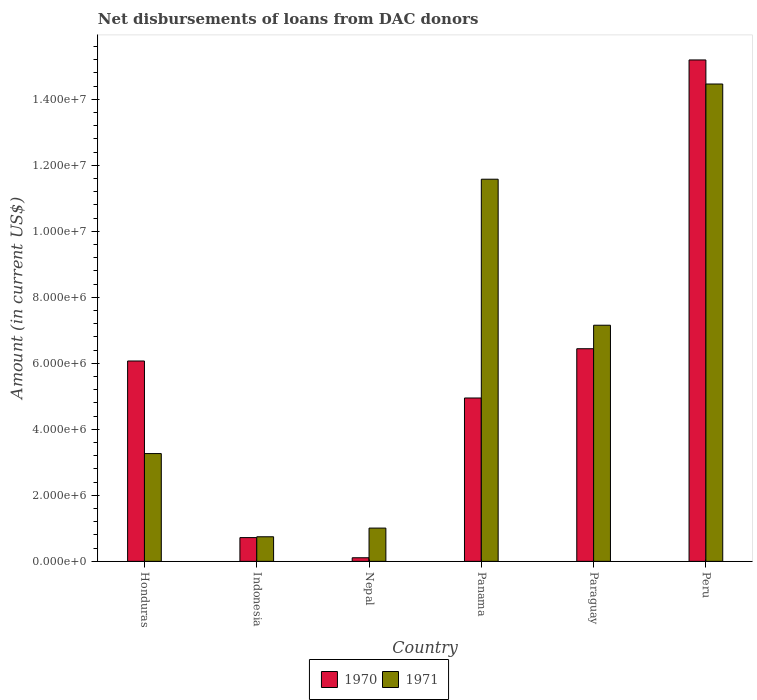How many different coloured bars are there?
Ensure brevity in your answer.  2. How many bars are there on the 5th tick from the right?
Provide a short and direct response. 2. What is the label of the 1st group of bars from the left?
Provide a short and direct response. Honduras. What is the amount of loans disbursed in 1970 in Honduras?
Give a very brief answer. 6.07e+06. Across all countries, what is the maximum amount of loans disbursed in 1970?
Your answer should be compact. 1.52e+07. Across all countries, what is the minimum amount of loans disbursed in 1970?
Offer a terse response. 1.09e+05. In which country was the amount of loans disbursed in 1971 maximum?
Your response must be concise. Peru. In which country was the amount of loans disbursed in 1971 minimum?
Keep it short and to the point. Indonesia. What is the total amount of loans disbursed in 1971 in the graph?
Make the answer very short. 3.82e+07. What is the difference between the amount of loans disbursed in 1970 in Honduras and that in Paraguay?
Your response must be concise. -3.72e+05. What is the difference between the amount of loans disbursed in 1970 in Indonesia and the amount of loans disbursed in 1971 in Paraguay?
Offer a terse response. -6.44e+06. What is the average amount of loans disbursed in 1970 per country?
Your answer should be compact. 5.58e+06. What is the difference between the amount of loans disbursed of/in 1970 and amount of loans disbursed of/in 1971 in Honduras?
Give a very brief answer. 2.80e+06. What is the ratio of the amount of loans disbursed in 1970 in Panama to that in Peru?
Offer a terse response. 0.33. What is the difference between the highest and the second highest amount of loans disbursed in 1970?
Offer a terse response. 8.75e+06. What is the difference between the highest and the lowest amount of loans disbursed in 1970?
Provide a short and direct response. 1.51e+07. Is the sum of the amount of loans disbursed in 1971 in Paraguay and Peru greater than the maximum amount of loans disbursed in 1970 across all countries?
Provide a succinct answer. Yes. What does the 2nd bar from the left in Indonesia represents?
Ensure brevity in your answer.  1971. What does the 1st bar from the right in Indonesia represents?
Offer a terse response. 1971. How many bars are there?
Your answer should be very brief. 12. How many countries are there in the graph?
Your response must be concise. 6. What is the difference between two consecutive major ticks on the Y-axis?
Offer a terse response. 2.00e+06. Does the graph contain any zero values?
Provide a short and direct response. No. Does the graph contain grids?
Offer a terse response. No. What is the title of the graph?
Offer a terse response. Net disbursements of loans from DAC donors. Does "1996" appear as one of the legend labels in the graph?
Your response must be concise. No. What is the Amount (in current US$) in 1970 in Honduras?
Your response must be concise. 6.07e+06. What is the Amount (in current US$) in 1971 in Honduras?
Your answer should be very brief. 3.27e+06. What is the Amount (in current US$) of 1970 in Indonesia?
Your response must be concise. 7.20e+05. What is the Amount (in current US$) in 1971 in Indonesia?
Keep it short and to the point. 7.45e+05. What is the Amount (in current US$) of 1970 in Nepal?
Your answer should be very brief. 1.09e+05. What is the Amount (in current US$) of 1971 in Nepal?
Your response must be concise. 1.01e+06. What is the Amount (in current US$) in 1970 in Panama?
Offer a terse response. 4.95e+06. What is the Amount (in current US$) of 1971 in Panama?
Provide a succinct answer. 1.16e+07. What is the Amount (in current US$) in 1970 in Paraguay?
Keep it short and to the point. 6.44e+06. What is the Amount (in current US$) in 1971 in Paraguay?
Ensure brevity in your answer.  7.16e+06. What is the Amount (in current US$) of 1970 in Peru?
Your answer should be compact. 1.52e+07. What is the Amount (in current US$) in 1971 in Peru?
Provide a succinct answer. 1.45e+07. Across all countries, what is the maximum Amount (in current US$) of 1970?
Ensure brevity in your answer.  1.52e+07. Across all countries, what is the maximum Amount (in current US$) in 1971?
Provide a succinct answer. 1.45e+07. Across all countries, what is the minimum Amount (in current US$) of 1970?
Your answer should be compact. 1.09e+05. Across all countries, what is the minimum Amount (in current US$) in 1971?
Offer a very short reply. 7.45e+05. What is the total Amount (in current US$) in 1970 in the graph?
Provide a succinct answer. 3.35e+07. What is the total Amount (in current US$) in 1971 in the graph?
Your answer should be compact. 3.82e+07. What is the difference between the Amount (in current US$) in 1970 in Honduras and that in Indonesia?
Keep it short and to the point. 5.35e+06. What is the difference between the Amount (in current US$) of 1971 in Honduras and that in Indonesia?
Your answer should be very brief. 2.52e+06. What is the difference between the Amount (in current US$) in 1970 in Honduras and that in Nepal?
Offer a very short reply. 5.96e+06. What is the difference between the Amount (in current US$) of 1971 in Honduras and that in Nepal?
Your answer should be compact. 2.26e+06. What is the difference between the Amount (in current US$) of 1970 in Honduras and that in Panama?
Make the answer very short. 1.12e+06. What is the difference between the Amount (in current US$) in 1971 in Honduras and that in Panama?
Make the answer very short. -8.31e+06. What is the difference between the Amount (in current US$) in 1970 in Honduras and that in Paraguay?
Your answer should be compact. -3.72e+05. What is the difference between the Amount (in current US$) of 1971 in Honduras and that in Paraguay?
Keep it short and to the point. -3.89e+06. What is the difference between the Amount (in current US$) of 1970 in Honduras and that in Peru?
Offer a very short reply. -9.12e+06. What is the difference between the Amount (in current US$) in 1971 in Honduras and that in Peru?
Your answer should be very brief. -1.12e+07. What is the difference between the Amount (in current US$) in 1970 in Indonesia and that in Nepal?
Make the answer very short. 6.11e+05. What is the difference between the Amount (in current US$) in 1971 in Indonesia and that in Nepal?
Give a very brief answer. -2.63e+05. What is the difference between the Amount (in current US$) of 1970 in Indonesia and that in Panama?
Your answer should be compact. -4.23e+06. What is the difference between the Amount (in current US$) in 1971 in Indonesia and that in Panama?
Make the answer very short. -1.08e+07. What is the difference between the Amount (in current US$) in 1970 in Indonesia and that in Paraguay?
Offer a very short reply. -5.72e+06. What is the difference between the Amount (in current US$) of 1971 in Indonesia and that in Paraguay?
Provide a succinct answer. -6.41e+06. What is the difference between the Amount (in current US$) in 1970 in Indonesia and that in Peru?
Provide a short and direct response. -1.45e+07. What is the difference between the Amount (in current US$) of 1971 in Indonesia and that in Peru?
Provide a short and direct response. -1.37e+07. What is the difference between the Amount (in current US$) in 1970 in Nepal and that in Panama?
Give a very brief answer. -4.84e+06. What is the difference between the Amount (in current US$) in 1971 in Nepal and that in Panama?
Your response must be concise. -1.06e+07. What is the difference between the Amount (in current US$) of 1970 in Nepal and that in Paraguay?
Your answer should be compact. -6.33e+06. What is the difference between the Amount (in current US$) in 1971 in Nepal and that in Paraguay?
Ensure brevity in your answer.  -6.15e+06. What is the difference between the Amount (in current US$) of 1970 in Nepal and that in Peru?
Provide a short and direct response. -1.51e+07. What is the difference between the Amount (in current US$) of 1971 in Nepal and that in Peru?
Ensure brevity in your answer.  -1.35e+07. What is the difference between the Amount (in current US$) of 1970 in Panama and that in Paraguay?
Make the answer very short. -1.49e+06. What is the difference between the Amount (in current US$) of 1971 in Panama and that in Paraguay?
Your response must be concise. 4.42e+06. What is the difference between the Amount (in current US$) in 1970 in Panama and that in Peru?
Offer a very short reply. -1.02e+07. What is the difference between the Amount (in current US$) in 1971 in Panama and that in Peru?
Keep it short and to the point. -2.88e+06. What is the difference between the Amount (in current US$) in 1970 in Paraguay and that in Peru?
Keep it short and to the point. -8.75e+06. What is the difference between the Amount (in current US$) of 1971 in Paraguay and that in Peru?
Offer a terse response. -7.31e+06. What is the difference between the Amount (in current US$) of 1970 in Honduras and the Amount (in current US$) of 1971 in Indonesia?
Provide a succinct answer. 5.33e+06. What is the difference between the Amount (in current US$) of 1970 in Honduras and the Amount (in current US$) of 1971 in Nepal?
Your response must be concise. 5.06e+06. What is the difference between the Amount (in current US$) of 1970 in Honduras and the Amount (in current US$) of 1971 in Panama?
Provide a succinct answer. -5.51e+06. What is the difference between the Amount (in current US$) in 1970 in Honduras and the Amount (in current US$) in 1971 in Paraguay?
Offer a very short reply. -1.08e+06. What is the difference between the Amount (in current US$) of 1970 in Honduras and the Amount (in current US$) of 1971 in Peru?
Give a very brief answer. -8.39e+06. What is the difference between the Amount (in current US$) in 1970 in Indonesia and the Amount (in current US$) in 1971 in Nepal?
Provide a succinct answer. -2.88e+05. What is the difference between the Amount (in current US$) of 1970 in Indonesia and the Amount (in current US$) of 1971 in Panama?
Your answer should be very brief. -1.09e+07. What is the difference between the Amount (in current US$) in 1970 in Indonesia and the Amount (in current US$) in 1971 in Paraguay?
Your answer should be compact. -6.44e+06. What is the difference between the Amount (in current US$) in 1970 in Indonesia and the Amount (in current US$) in 1971 in Peru?
Provide a succinct answer. -1.37e+07. What is the difference between the Amount (in current US$) in 1970 in Nepal and the Amount (in current US$) in 1971 in Panama?
Give a very brief answer. -1.15e+07. What is the difference between the Amount (in current US$) in 1970 in Nepal and the Amount (in current US$) in 1971 in Paraguay?
Your response must be concise. -7.05e+06. What is the difference between the Amount (in current US$) in 1970 in Nepal and the Amount (in current US$) in 1971 in Peru?
Make the answer very short. -1.44e+07. What is the difference between the Amount (in current US$) in 1970 in Panama and the Amount (in current US$) in 1971 in Paraguay?
Your response must be concise. -2.20e+06. What is the difference between the Amount (in current US$) of 1970 in Panama and the Amount (in current US$) of 1971 in Peru?
Provide a short and direct response. -9.51e+06. What is the difference between the Amount (in current US$) in 1970 in Paraguay and the Amount (in current US$) in 1971 in Peru?
Offer a very short reply. -8.02e+06. What is the average Amount (in current US$) of 1970 per country?
Provide a short and direct response. 5.58e+06. What is the average Amount (in current US$) in 1971 per country?
Ensure brevity in your answer.  6.37e+06. What is the difference between the Amount (in current US$) of 1970 and Amount (in current US$) of 1971 in Honduras?
Offer a very short reply. 2.80e+06. What is the difference between the Amount (in current US$) in 1970 and Amount (in current US$) in 1971 in Indonesia?
Offer a terse response. -2.50e+04. What is the difference between the Amount (in current US$) in 1970 and Amount (in current US$) in 1971 in Nepal?
Your answer should be very brief. -8.99e+05. What is the difference between the Amount (in current US$) of 1970 and Amount (in current US$) of 1971 in Panama?
Your response must be concise. -6.63e+06. What is the difference between the Amount (in current US$) of 1970 and Amount (in current US$) of 1971 in Paraguay?
Offer a terse response. -7.12e+05. What is the difference between the Amount (in current US$) of 1970 and Amount (in current US$) of 1971 in Peru?
Your answer should be very brief. 7.29e+05. What is the ratio of the Amount (in current US$) of 1970 in Honduras to that in Indonesia?
Keep it short and to the point. 8.43. What is the ratio of the Amount (in current US$) in 1971 in Honduras to that in Indonesia?
Give a very brief answer. 4.38. What is the ratio of the Amount (in current US$) of 1970 in Honduras to that in Nepal?
Ensure brevity in your answer.  55.7. What is the ratio of the Amount (in current US$) of 1971 in Honduras to that in Nepal?
Provide a succinct answer. 3.24. What is the ratio of the Amount (in current US$) in 1970 in Honduras to that in Panama?
Provide a succinct answer. 1.23. What is the ratio of the Amount (in current US$) in 1971 in Honduras to that in Panama?
Keep it short and to the point. 0.28. What is the ratio of the Amount (in current US$) of 1970 in Honduras to that in Paraguay?
Your response must be concise. 0.94. What is the ratio of the Amount (in current US$) of 1971 in Honduras to that in Paraguay?
Make the answer very short. 0.46. What is the ratio of the Amount (in current US$) of 1970 in Honduras to that in Peru?
Make the answer very short. 0.4. What is the ratio of the Amount (in current US$) of 1971 in Honduras to that in Peru?
Your response must be concise. 0.23. What is the ratio of the Amount (in current US$) in 1970 in Indonesia to that in Nepal?
Your answer should be very brief. 6.61. What is the ratio of the Amount (in current US$) in 1971 in Indonesia to that in Nepal?
Your answer should be compact. 0.74. What is the ratio of the Amount (in current US$) in 1970 in Indonesia to that in Panama?
Ensure brevity in your answer.  0.15. What is the ratio of the Amount (in current US$) in 1971 in Indonesia to that in Panama?
Give a very brief answer. 0.06. What is the ratio of the Amount (in current US$) in 1970 in Indonesia to that in Paraguay?
Provide a short and direct response. 0.11. What is the ratio of the Amount (in current US$) of 1971 in Indonesia to that in Paraguay?
Your response must be concise. 0.1. What is the ratio of the Amount (in current US$) of 1970 in Indonesia to that in Peru?
Make the answer very short. 0.05. What is the ratio of the Amount (in current US$) in 1971 in Indonesia to that in Peru?
Keep it short and to the point. 0.05. What is the ratio of the Amount (in current US$) in 1970 in Nepal to that in Panama?
Offer a terse response. 0.02. What is the ratio of the Amount (in current US$) of 1971 in Nepal to that in Panama?
Provide a short and direct response. 0.09. What is the ratio of the Amount (in current US$) of 1970 in Nepal to that in Paraguay?
Your answer should be compact. 0.02. What is the ratio of the Amount (in current US$) of 1971 in Nepal to that in Paraguay?
Offer a terse response. 0.14. What is the ratio of the Amount (in current US$) in 1970 in Nepal to that in Peru?
Give a very brief answer. 0.01. What is the ratio of the Amount (in current US$) in 1971 in Nepal to that in Peru?
Provide a succinct answer. 0.07. What is the ratio of the Amount (in current US$) in 1970 in Panama to that in Paraguay?
Give a very brief answer. 0.77. What is the ratio of the Amount (in current US$) in 1971 in Panama to that in Paraguay?
Provide a short and direct response. 1.62. What is the ratio of the Amount (in current US$) in 1970 in Panama to that in Peru?
Ensure brevity in your answer.  0.33. What is the ratio of the Amount (in current US$) of 1971 in Panama to that in Peru?
Your answer should be very brief. 0.8. What is the ratio of the Amount (in current US$) of 1970 in Paraguay to that in Peru?
Offer a very short reply. 0.42. What is the ratio of the Amount (in current US$) in 1971 in Paraguay to that in Peru?
Provide a succinct answer. 0.49. What is the difference between the highest and the second highest Amount (in current US$) of 1970?
Your response must be concise. 8.75e+06. What is the difference between the highest and the second highest Amount (in current US$) in 1971?
Your answer should be compact. 2.88e+06. What is the difference between the highest and the lowest Amount (in current US$) in 1970?
Keep it short and to the point. 1.51e+07. What is the difference between the highest and the lowest Amount (in current US$) in 1971?
Give a very brief answer. 1.37e+07. 